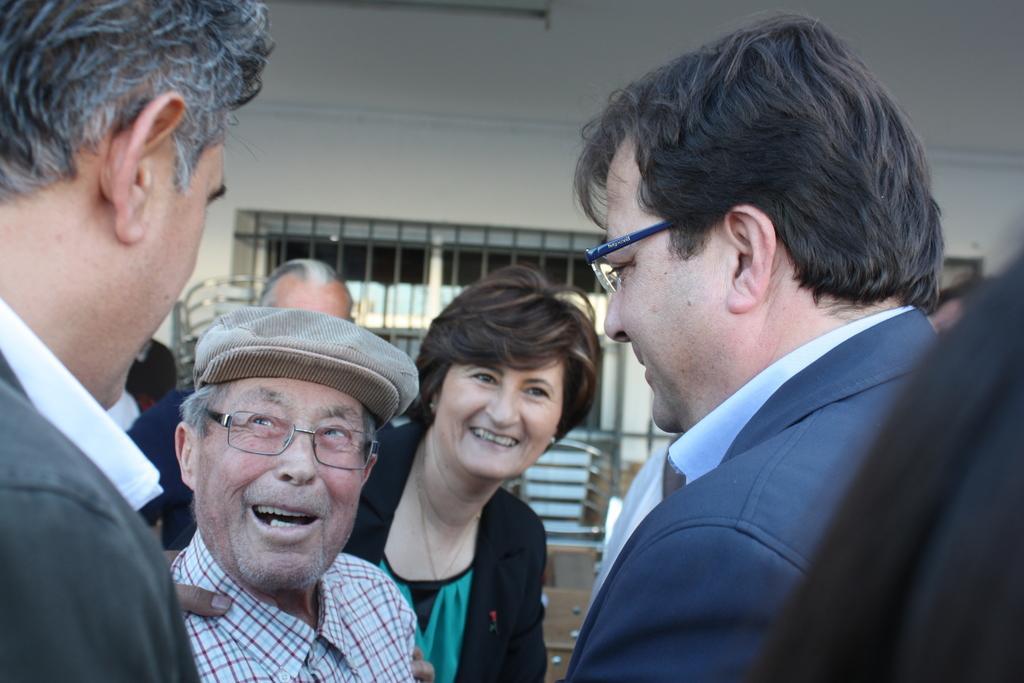How would you summarize this image in a sentence or two? In the foreground of this image, there are people. In the background, there is a wall, window and it seems like chair. 